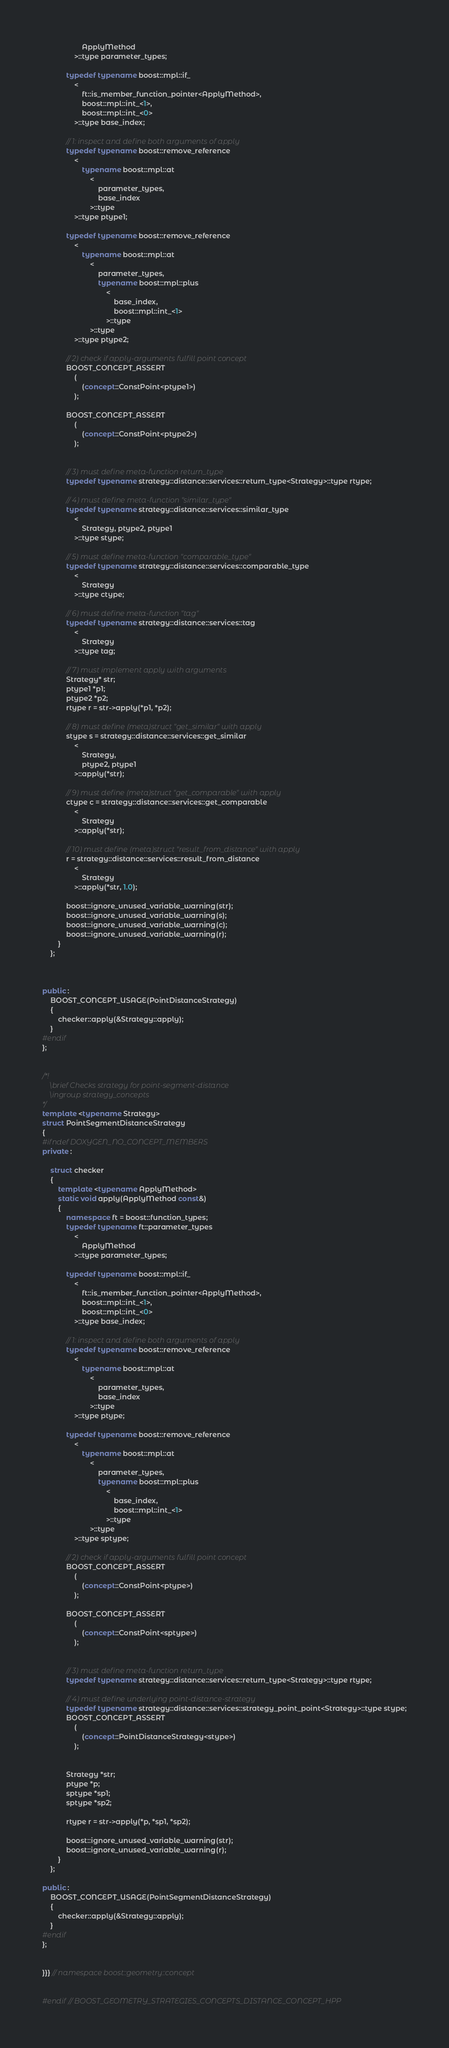Convert code to text. <code><loc_0><loc_0><loc_500><loc_500><_C++_>                    ApplyMethod
                >::type parameter_types;

            typedef typename boost::mpl::if_
                <
                    ft::is_member_function_pointer<ApplyMethod>,
                    boost::mpl::int_<1>,
                    boost::mpl::int_<0>
                >::type base_index;

            // 1: inspect and define both arguments of apply
            typedef typename boost::remove_reference
                <
                    typename boost::mpl::at
                        <
                            parameter_types,
                            base_index
                        >::type
                >::type ptype1;

            typedef typename boost::remove_reference
                <
                    typename boost::mpl::at
                        <
                            parameter_types,
                            typename boost::mpl::plus
                                <
                                    base_index,
                                    boost::mpl::int_<1>
                                >::type
                        >::type
                >::type ptype2;

            // 2) check if apply-arguments fulfill point concept
            BOOST_CONCEPT_ASSERT
                (
                    (concept::ConstPoint<ptype1>)
                );

            BOOST_CONCEPT_ASSERT
                (
                    (concept::ConstPoint<ptype2>)
                );


            // 3) must define meta-function return_type
            typedef typename strategy::distance::services::return_type<Strategy>::type rtype;

            // 4) must define meta-function "similar_type"
            typedef typename strategy::distance::services::similar_type
                <
                    Strategy, ptype2, ptype1
                >::type stype;

            // 5) must define meta-function "comparable_type"
            typedef typename strategy::distance::services::comparable_type
                <
                    Strategy
                >::type ctype;

            // 6) must define meta-function "tag"
            typedef typename strategy::distance::services::tag
                <
                    Strategy
                >::type tag;

            // 7) must implement apply with arguments
            Strategy* str;
            ptype1 *p1;
            ptype2 *p2;
            rtype r = str->apply(*p1, *p2);

            // 8) must define (meta)struct "get_similar" with apply
            stype s = strategy::distance::services::get_similar
                <
                    Strategy,
                    ptype2, ptype1
                >::apply(*str);

            // 9) must define (meta)struct "get_comparable" with apply
            ctype c = strategy::distance::services::get_comparable
                <
                    Strategy
                >::apply(*str);

            // 10) must define (meta)struct "result_from_distance" with apply
            r = strategy::distance::services::result_from_distance
                <
                    Strategy
                >::apply(*str, 1.0);

            boost::ignore_unused_variable_warning(str);
            boost::ignore_unused_variable_warning(s);
            boost::ignore_unused_variable_warning(c);
            boost::ignore_unused_variable_warning(r);
        }
    };



public :
    BOOST_CONCEPT_USAGE(PointDistanceStrategy)
    {
        checker::apply(&Strategy::apply);
    }
#endif
};


/*!
    \brief Checks strategy for point-segment-distance
    \ingroup strategy_concepts
*/
template <typename Strategy>
struct PointSegmentDistanceStrategy
{
#ifndef DOXYGEN_NO_CONCEPT_MEMBERS
private :

    struct checker
    {
        template <typename ApplyMethod>
        static void apply(ApplyMethod const&)
        {
            namespace ft = boost::function_types;
            typedef typename ft::parameter_types
                <
                    ApplyMethod
                >::type parameter_types;

            typedef typename boost::mpl::if_
                <
                    ft::is_member_function_pointer<ApplyMethod>,
                    boost::mpl::int_<1>,
                    boost::mpl::int_<0>
                >::type base_index;

            // 1: inspect and define both arguments of apply
            typedef typename boost::remove_reference
                <
                    typename boost::mpl::at
                        <
                            parameter_types,
                            base_index
                        >::type
                >::type ptype;

            typedef typename boost::remove_reference
                <
                    typename boost::mpl::at
                        <
                            parameter_types,
                            typename boost::mpl::plus
                                <
                                    base_index,
                                    boost::mpl::int_<1>
                                >::type
                        >::type
                >::type sptype;

            // 2) check if apply-arguments fulfill point concept
            BOOST_CONCEPT_ASSERT
                (
                    (concept::ConstPoint<ptype>)
                );

            BOOST_CONCEPT_ASSERT
                (
                    (concept::ConstPoint<sptype>)
                );


            // 3) must define meta-function return_type
            typedef typename strategy::distance::services::return_type<Strategy>::type rtype;

            // 4) must define underlying point-distance-strategy
            typedef typename strategy::distance::services::strategy_point_point<Strategy>::type stype;
            BOOST_CONCEPT_ASSERT
                (
                    (concept::PointDistanceStrategy<stype>)
                );


            Strategy *str;
            ptype *p;
            sptype *sp1;
            sptype *sp2;

            rtype r = str->apply(*p, *sp1, *sp2);

            boost::ignore_unused_variable_warning(str);
            boost::ignore_unused_variable_warning(r);
        }
    };

public :
    BOOST_CONCEPT_USAGE(PointSegmentDistanceStrategy)
    {
        checker::apply(&Strategy::apply);
    }
#endif
};


}}} // namespace boost::geometry::concept


#endif // BOOST_GEOMETRY_STRATEGIES_CONCEPTS_DISTANCE_CONCEPT_HPP
</code> 